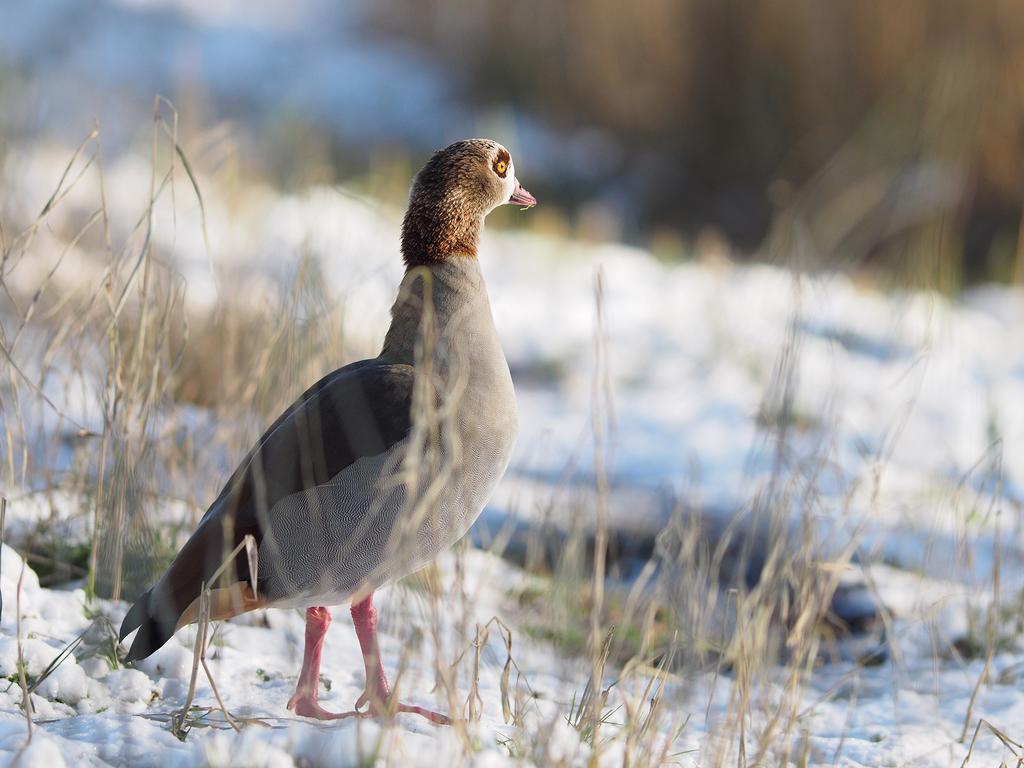Please provide a concise description of this image. In this image, on the left side, we can see a bird standing on the snow. In the background, we can see some plants, grass. At the bottom, we can see a snow. 